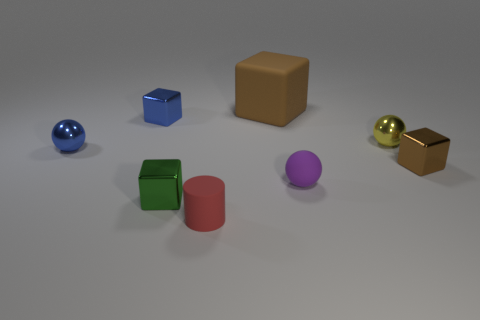Subtract all tiny yellow metallic spheres. How many spheres are left? 2 Add 1 tiny yellow shiny cylinders. How many objects exist? 9 Subtract all cyan cylinders. How many brown blocks are left? 2 Subtract 3 balls. How many balls are left? 0 Subtract all balls. How many objects are left? 5 Subtract all green cubes. How many cubes are left? 3 Subtract all yellow cubes. Subtract all blue cylinders. How many cubes are left? 4 Subtract all green cubes. Subtract all small yellow metal balls. How many objects are left? 6 Add 3 tiny green shiny blocks. How many tiny green shiny blocks are left? 4 Add 2 small red metallic things. How many small red metallic things exist? 2 